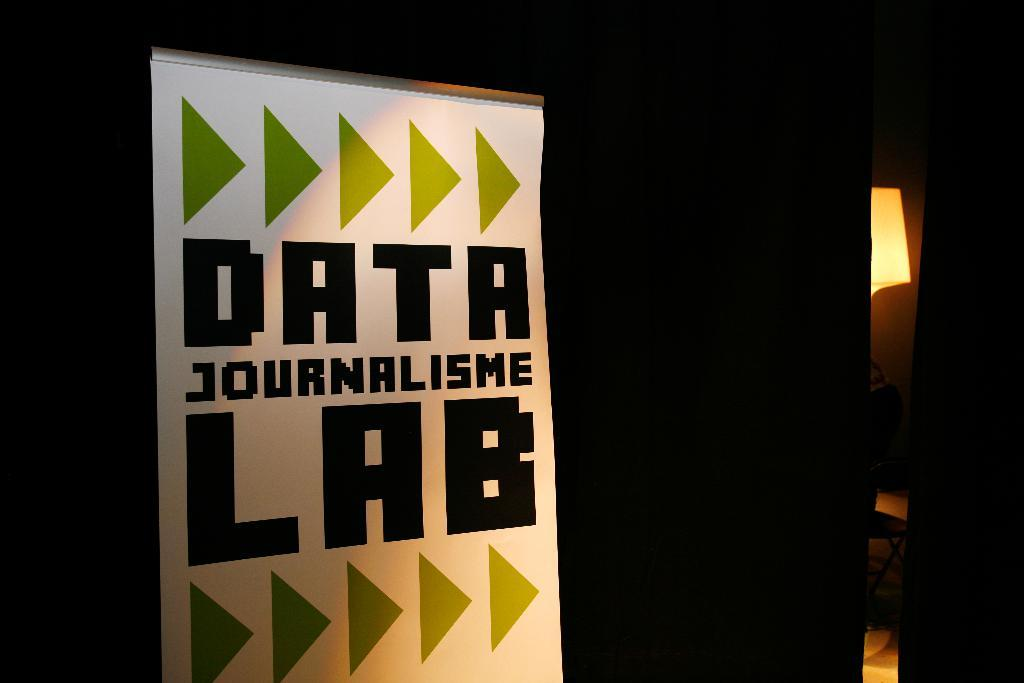Provide a one-sentence caption for the provided image. a poster that has the word Data at the top. 